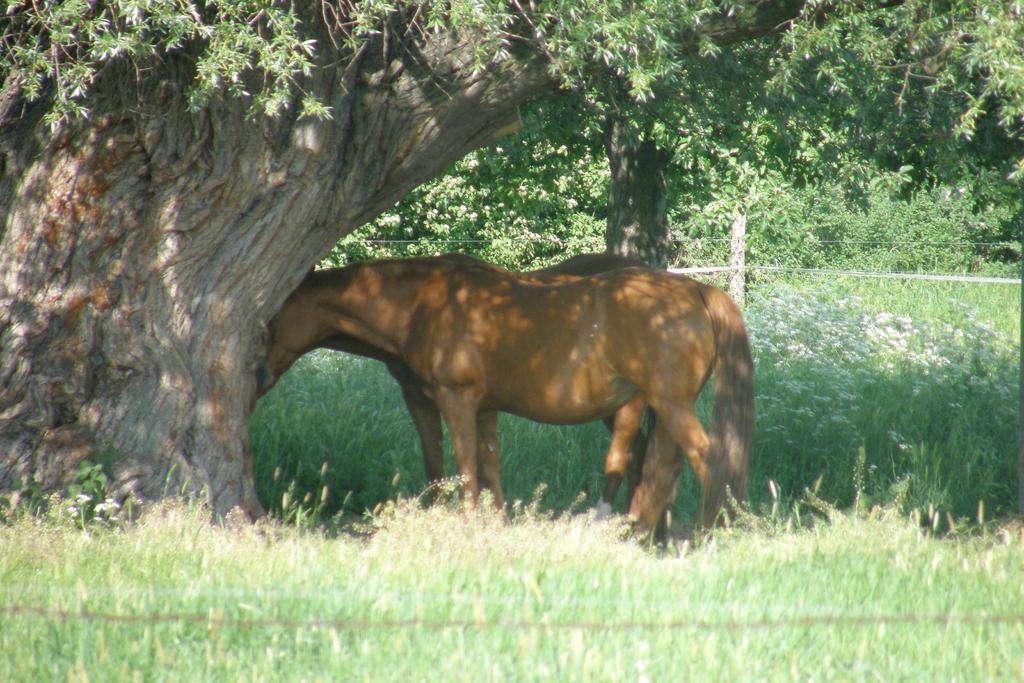How would you summarize this image in a sentence or two? This picture consists of forest , in the forest I can see trees and bushes and a pole visible in the middle and I can see two animals visible in front of tree. 